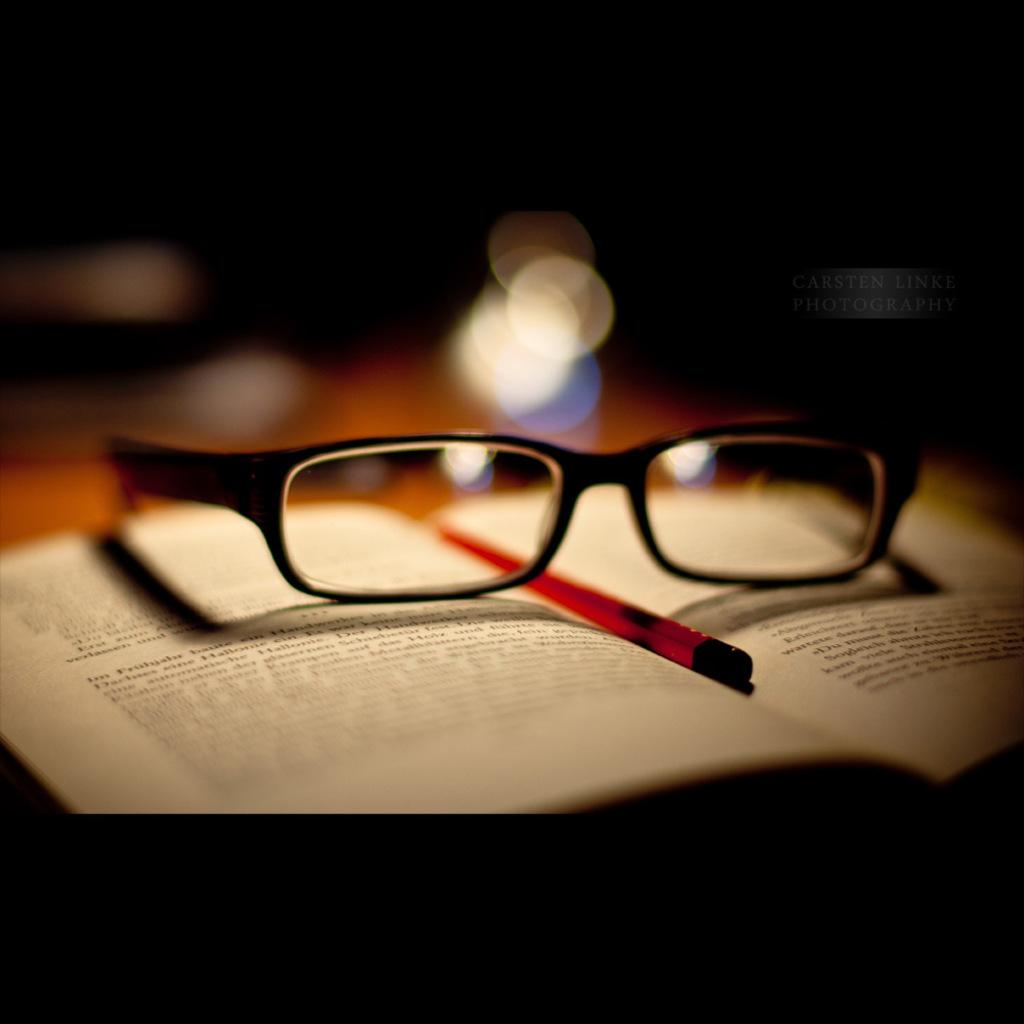What stationery item is present in the image? There is a pen in the image. What other object related to vision can be seen in the image? There are spectacles in the image. Where are the pen and spectacles located? The pen and spectacles are on a book. What can be seen in the background of the image? There are lights visible in the background of the image. How does the goose show respect in the image? There is no goose present in the image, so it cannot show respect or perform any actions. 